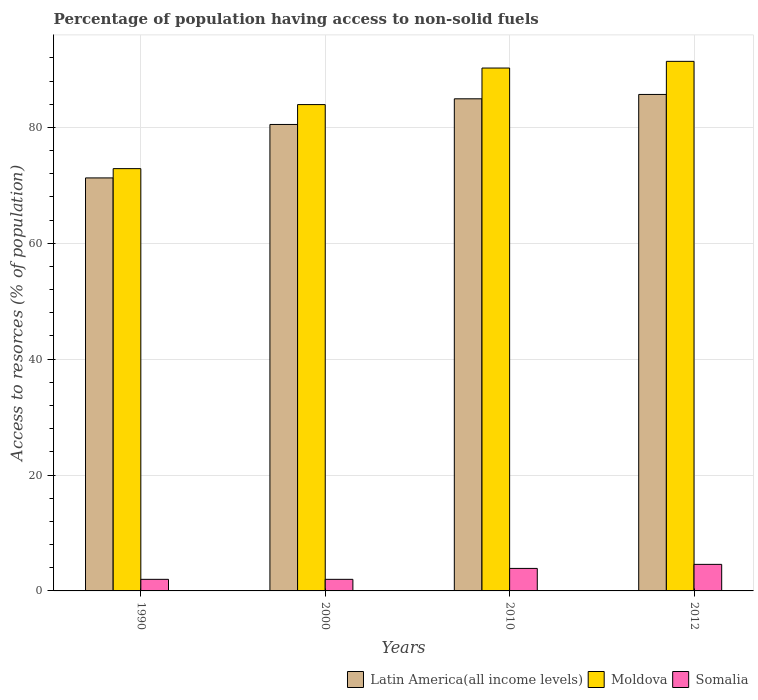Are the number of bars on each tick of the X-axis equal?
Offer a terse response. Yes. How many bars are there on the 2nd tick from the right?
Offer a terse response. 3. In how many cases, is the number of bars for a given year not equal to the number of legend labels?
Provide a short and direct response. 0. What is the percentage of population having access to non-solid fuels in Somalia in 2012?
Give a very brief answer. 4.58. Across all years, what is the maximum percentage of population having access to non-solid fuels in Moldova?
Your response must be concise. 91.4. Across all years, what is the minimum percentage of population having access to non-solid fuels in Moldova?
Offer a very short reply. 72.88. In which year was the percentage of population having access to non-solid fuels in Latin America(all income levels) maximum?
Offer a terse response. 2012. What is the total percentage of population having access to non-solid fuels in Moldova in the graph?
Your response must be concise. 338.45. What is the difference between the percentage of population having access to non-solid fuels in Latin America(all income levels) in 1990 and that in 2000?
Make the answer very short. -9.23. What is the difference between the percentage of population having access to non-solid fuels in Latin America(all income levels) in 2000 and the percentage of population having access to non-solid fuels in Moldova in 2010?
Ensure brevity in your answer.  -9.74. What is the average percentage of population having access to non-solid fuels in Somalia per year?
Your answer should be very brief. 3.12. In the year 1990, what is the difference between the percentage of population having access to non-solid fuels in Somalia and percentage of population having access to non-solid fuels in Latin America(all income levels)?
Offer a very short reply. -69.28. In how many years, is the percentage of population having access to non-solid fuels in Somalia greater than 44 %?
Provide a succinct answer. 0. What is the ratio of the percentage of population having access to non-solid fuels in Moldova in 1990 to that in 2000?
Offer a terse response. 0.87. What is the difference between the highest and the second highest percentage of population having access to non-solid fuels in Latin America(all income levels)?
Your answer should be very brief. 0.75. What is the difference between the highest and the lowest percentage of population having access to non-solid fuels in Latin America(all income levels)?
Your answer should be very brief. 14.41. Is the sum of the percentage of population having access to non-solid fuels in Moldova in 2000 and 2010 greater than the maximum percentage of population having access to non-solid fuels in Latin America(all income levels) across all years?
Keep it short and to the point. Yes. What does the 1st bar from the left in 1990 represents?
Offer a terse response. Latin America(all income levels). What does the 2nd bar from the right in 2010 represents?
Keep it short and to the point. Moldova. Is it the case that in every year, the sum of the percentage of population having access to non-solid fuels in Latin America(all income levels) and percentage of population having access to non-solid fuels in Somalia is greater than the percentage of population having access to non-solid fuels in Moldova?
Your answer should be very brief. No. How many bars are there?
Your answer should be very brief. 12. How many years are there in the graph?
Keep it short and to the point. 4. Does the graph contain any zero values?
Provide a succinct answer. No. Does the graph contain grids?
Make the answer very short. Yes. Where does the legend appear in the graph?
Your response must be concise. Bottom right. How many legend labels are there?
Provide a succinct answer. 3. What is the title of the graph?
Your answer should be compact. Percentage of population having access to non-solid fuels. Does "United States" appear as one of the legend labels in the graph?
Keep it short and to the point. No. What is the label or title of the Y-axis?
Your answer should be compact. Access to resorces (% of population). What is the Access to resorces (% of population) of Latin America(all income levels) in 1990?
Make the answer very short. 71.28. What is the Access to resorces (% of population) of Moldova in 1990?
Your answer should be compact. 72.88. What is the Access to resorces (% of population) in Somalia in 1990?
Ensure brevity in your answer.  2. What is the Access to resorces (% of population) in Latin America(all income levels) in 2000?
Your response must be concise. 80.51. What is the Access to resorces (% of population) of Moldova in 2000?
Offer a terse response. 83.93. What is the Access to resorces (% of population) in Somalia in 2000?
Give a very brief answer. 2. What is the Access to resorces (% of population) of Latin America(all income levels) in 2010?
Give a very brief answer. 84.93. What is the Access to resorces (% of population) in Moldova in 2010?
Provide a short and direct response. 90.24. What is the Access to resorces (% of population) of Somalia in 2010?
Make the answer very short. 3.89. What is the Access to resorces (% of population) of Latin America(all income levels) in 2012?
Your response must be concise. 85.68. What is the Access to resorces (% of population) of Moldova in 2012?
Offer a very short reply. 91.4. What is the Access to resorces (% of population) of Somalia in 2012?
Give a very brief answer. 4.58. Across all years, what is the maximum Access to resorces (% of population) of Latin America(all income levels)?
Offer a terse response. 85.68. Across all years, what is the maximum Access to resorces (% of population) in Moldova?
Provide a succinct answer. 91.4. Across all years, what is the maximum Access to resorces (% of population) of Somalia?
Your answer should be compact. 4.58. Across all years, what is the minimum Access to resorces (% of population) in Latin America(all income levels)?
Give a very brief answer. 71.28. Across all years, what is the minimum Access to resorces (% of population) of Moldova?
Give a very brief answer. 72.88. Across all years, what is the minimum Access to resorces (% of population) in Somalia?
Your response must be concise. 2. What is the total Access to resorces (% of population) in Latin America(all income levels) in the graph?
Your response must be concise. 322.4. What is the total Access to resorces (% of population) in Moldova in the graph?
Keep it short and to the point. 338.45. What is the total Access to resorces (% of population) in Somalia in the graph?
Make the answer very short. 12.47. What is the difference between the Access to resorces (% of population) of Latin America(all income levels) in 1990 and that in 2000?
Provide a succinct answer. -9.23. What is the difference between the Access to resorces (% of population) in Moldova in 1990 and that in 2000?
Provide a short and direct response. -11.05. What is the difference between the Access to resorces (% of population) in Somalia in 1990 and that in 2000?
Your response must be concise. 0. What is the difference between the Access to resorces (% of population) in Latin America(all income levels) in 1990 and that in 2010?
Offer a very short reply. -13.65. What is the difference between the Access to resorces (% of population) of Moldova in 1990 and that in 2010?
Your answer should be very brief. -17.36. What is the difference between the Access to resorces (% of population) of Somalia in 1990 and that in 2010?
Keep it short and to the point. -1.89. What is the difference between the Access to resorces (% of population) in Latin America(all income levels) in 1990 and that in 2012?
Provide a succinct answer. -14.41. What is the difference between the Access to resorces (% of population) in Moldova in 1990 and that in 2012?
Give a very brief answer. -18.52. What is the difference between the Access to resorces (% of population) in Somalia in 1990 and that in 2012?
Ensure brevity in your answer.  -2.58. What is the difference between the Access to resorces (% of population) in Latin America(all income levels) in 2000 and that in 2010?
Make the answer very short. -4.43. What is the difference between the Access to resorces (% of population) in Moldova in 2000 and that in 2010?
Give a very brief answer. -6.31. What is the difference between the Access to resorces (% of population) in Somalia in 2000 and that in 2010?
Provide a short and direct response. -1.89. What is the difference between the Access to resorces (% of population) of Latin America(all income levels) in 2000 and that in 2012?
Provide a succinct answer. -5.18. What is the difference between the Access to resorces (% of population) in Moldova in 2000 and that in 2012?
Your answer should be compact. -7.46. What is the difference between the Access to resorces (% of population) in Somalia in 2000 and that in 2012?
Your response must be concise. -2.58. What is the difference between the Access to resorces (% of population) in Latin America(all income levels) in 2010 and that in 2012?
Your answer should be compact. -0.75. What is the difference between the Access to resorces (% of population) in Moldova in 2010 and that in 2012?
Offer a very short reply. -1.15. What is the difference between the Access to resorces (% of population) in Somalia in 2010 and that in 2012?
Give a very brief answer. -0.7. What is the difference between the Access to resorces (% of population) in Latin America(all income levels) in 1990 and the Access to resorces (% of population) in Moldova in 2000?
Offer a very short reply. -12.66. What is the difference between the Access to resorces (% of population) of Latin America(all income levels) in 1990 and the Access to resorces (% of population) of Somalia in 2000?
Your answer should be very brief. 69.28. What is the difference between the Access to resorces (% of population) of Moldova in 1990 and the Access to resorces (% of population) of Somalia in 2000?
Your response must be concise. 70.88. What is the difference between the Access to resorces (% of population) in Latin America(all income levels) in 1990 and the Access to resorces (% of population) in Moldova in 2010?
Provide a short and direct response. -18.96. What is the difference between the Access to resorces (% of population) of Latin America(all income levels) in 1990 and the Access to resorces (% of population) of Somalia in 2010?
Offer a very short reply. 67.39. What is the difference between the Access to resorces (% of population) in Moldova in 1990 and the Access to resorces (% of population) in Somalia in 2010?
Offer a terse response. 68.99. What is the difference between the Access to resorces (% of population) of Latin America(all income levels) in 1990 and the Access to resorces (% of population) of Moldova in 2012?
Your answer should be compact. -20.12. What is the difference between the Access to resorces (% of population) in Latin America(all income levels) in 1990 and the Access to resorces (% of population) in Somalia in 2012?
Provide a short and direct response. 66.7. What is the difference between the Access to resorces (% of population) of Moldova in 1990 and the Access to resorces (% of population) of Somalia in 2012?
Ensure brevity in your answer.  68.3. What is the difference between the Access to resorces (% of population) of Latin America(all income levels) in 2000 and the Access to resorces (% of population) of Moldova in 2010?
Offer a very short reply. -9.74. What is the difference between the Access to resorces (% of population) in Latin America(all income levels) in 2000 and the Access to resorces (% of population) in Somalia in 2010?
Your response must be concise. 76.62. What is the difference between the Access to resorces (% of population) in Moldova in 2000 and the Access to resorces (% of population) in Somalia in 2010?
Provide a short and direct response. 80.05. What is the difference between the Access to resorces (% of population) in Latin America(all income levels) in 2000 and the Access to resorces (% of population) in Moldova in 2012?
Provide a short and direct response. -10.89. What is the difference between the Access to resorces (% of population) in Latin America(all income levels) in 2000 and the Access to resorces (% of population) in Somalia in 2012?
Offer a very short reply. 75.92. What is the difference between the Access to resorces (% of population) of Moldova in 2000 and the Access to resorces (% of population) of Somalia in 2012?
Your answer should be very brief. 79.35. What is the difference between the Access to resorces (% of population) in Latin America(all income levels) in 2010 and the Access to resorces (% of population) in Moldova in 2012?
Your answer should be compact. -6.46. What is the difference between the Access to resorces (% of population) in Latin America(all income levels) in 2010 and the Access to resorces (% of population) in Somalia in 2012?
Provide a succinct answer. 80.35. What is the difference between the Access to resorces (% of population) in Moldova in 2010 and the Access to resorces (% of population) in Somalia in 2012?
Offer a terse response. 85.66. What is the average Access to resorces (% of population) of Latin America(all income levels) per year?
Offer a terse response. 80.6. What is the average Access to resorces (% of population) in Moldova per year?
Your response must be concise. 84.61. What is the average Access to resorces (% of population) of Somalia per year?
Your answer should be very brief. 3.12. In the year 1990, what is the difference between the Access to resorces (% of population) in Latin America(all income levels) and Access to resorces (% of population) in Moldova?
Ensure brevity in your answer.  -1.6. In the year 1990, what is the difference between the Access to resorces (% of population) of Latin America(all income levels) and Access to resorces (% of population) of Somalia?
Keep it short and to the point. 69.28. In the year 1990, what is the difference between the Access to resorces (% of population) of Moldova and Access to resorces (% of population) of Somalia?
Your answer should be very brief. 70.88. In the year 2000, what is the difference between the Access to resorces (% of population) in Latin America(all income levels) and Access to resorces (% of population) in Moldova?
Your response must be concise. -3.43. In the year 2000, what is the difference between the Access to resorces (% of population) in Latin America(all income levels) and Access to resorces (% of population) in Somalia?
Ensure brevity in your answer.  78.51. In the year 2000, what is the difference between the Access to resorces (% of population) of Moldova and Access to resorces (% of population) of Somalia?
Your response must be concise. 81.93. In the year 2010, what is the difference between the Access to resorces (% of population) in Latin America(all income levels) and Access to resorces (% of population) in Moldova?
Provide a short and direct response. -5.31. In the year 2010, what is the difference between the Access to resorces (% of population) in Latin America(all income levels) and Access to resorces (% of population) in Somalia?
Provide a succinct answer. 81.05. In the year 2010, what is the difference between the Access to resorces (% of population) in Moldova and Access to resorces (% of population) in Somalia?
Give a very brief answer. 86.36. In the year 2012, what is the difference between the Access to resorces (% of population) in Latin America(all income levels) and Access to resorces (% of population) in Moldova?
Offer a terse response. -5.71. In the year 2012, what is the difference between the Access to resorces (% of population) of Latin America(all income levels) and Access to resorces (% of population) of Somalia?
Keep it short and to the point. 81.1. In the year 2012, what is the difference between the Access to resorces (% of population) of Moldova and Access to resorces (% of population) of Somalia?
Provide a short and direct response. 86.81. What is the ratio of the Access to resorces (% of population) of Latin America(all income levels) in 1990 to that in 2000?
Your response must be concise. 0.89. What is the ratio of the Access to resorces (% of population) in Moldova in 1990 to that in 2000?
Make the answer very short. 0.87. What is the ratio of the Access to resorces (% of population) in Somalia in 1990 to that in 2000?
Make the answer very short. 1. What is the ratio of the Access to resorces (% of population) in Latin America(all income levels) in 1990 to that in 2010?
Keep it short and to the point. 0.84. What is the ratio of the Access to resorces (% of population) in Moldova in 1990 to that in 2010?
Give a very brief answer. 0.81. What is the ratio of the Access to resorces (% of population) in Somalia in 1990 to that in 2010?
Give a very brief answer. 0.51. What is the ratio of the Access to resorces (% of population) in Latin America(all income levels) in 1990 to that in 2012?
Offer a very short reply. 0.83. What is the ratio of the Access to resorces (% of population) in Moldova in 1990 to that in 2012?
Your answer should be very brief. 0.8. What is the ratio of the Access to resorces (% of population) of Somalia in 1990 to that in 2012?
Your response must be concise. 0.44. What is the ratio of the Access to resorces (% of population) of Latin America(all income levels) in 2000 to that in 2010?
Provide a succinct answer. 0.95. What is the ratio of the Access to resorces (% of population) in Moldova in 2000 to that in 2010?
Ensure brevity in your answer.  0.93. What is the ratio of the Access to resorces (% of population) in Somalia in 2000 to that in 2010?
Offer a very short reply. 0.51. What is the ratio of the Access to resorces (% of population) of Latin America(all income levels) in 2000 to that in 2012?
Your response must be concise. 0.94. What is the ratio of the Access to resorces (% of population) in Moldova in 2000 to that in 2012?
Make the answer very short. 0.92. What is the ratio of the Access to resorces (% of population) in Somalia in 2000 to that in 2012?
Provide a short and direct response. 0.44. What is the ratio of the Access to resorces (% of population) of Latin America(all income levels) in 2010 to that in 2012?
Your response must be concise. 0.99. What is the ratio of the Access to resorces (% of population) of Moldova in 2010 to that in 2012?
Make the answer very short. 0.99. What is the ratio of the Access to resorces (% of population) in Somalia in 2010 to that in 2012?
Give a very brief answer. 0.85. What is the difference between the highest and the second highest Access to resorces (% of population) of Latin America(all income levels)?
Provide a short and direct response. 0.75. What is the difference between the highest and the second highest Access to resorces (% of population) of Moldova?
Offer a very short reply. 1.15. What is the difference between the highest and the second highest Access to resorces (% of population) of Somalia?
Your response must be concise. 0.7. What is the difference between the highest and the lowest Access to resorces (% of population) in Latin America(all income levels)?
Keep it short and to the point. 14.41. What is the difference between the highest and the lowest Access to resorces (% of population) in Moldova?
Keep it short and to the point. 18.52. What is the difference between the highest and the lowest Access to resorces (% of population) of Somalia?
Keep it short and to the point. 2.58. 